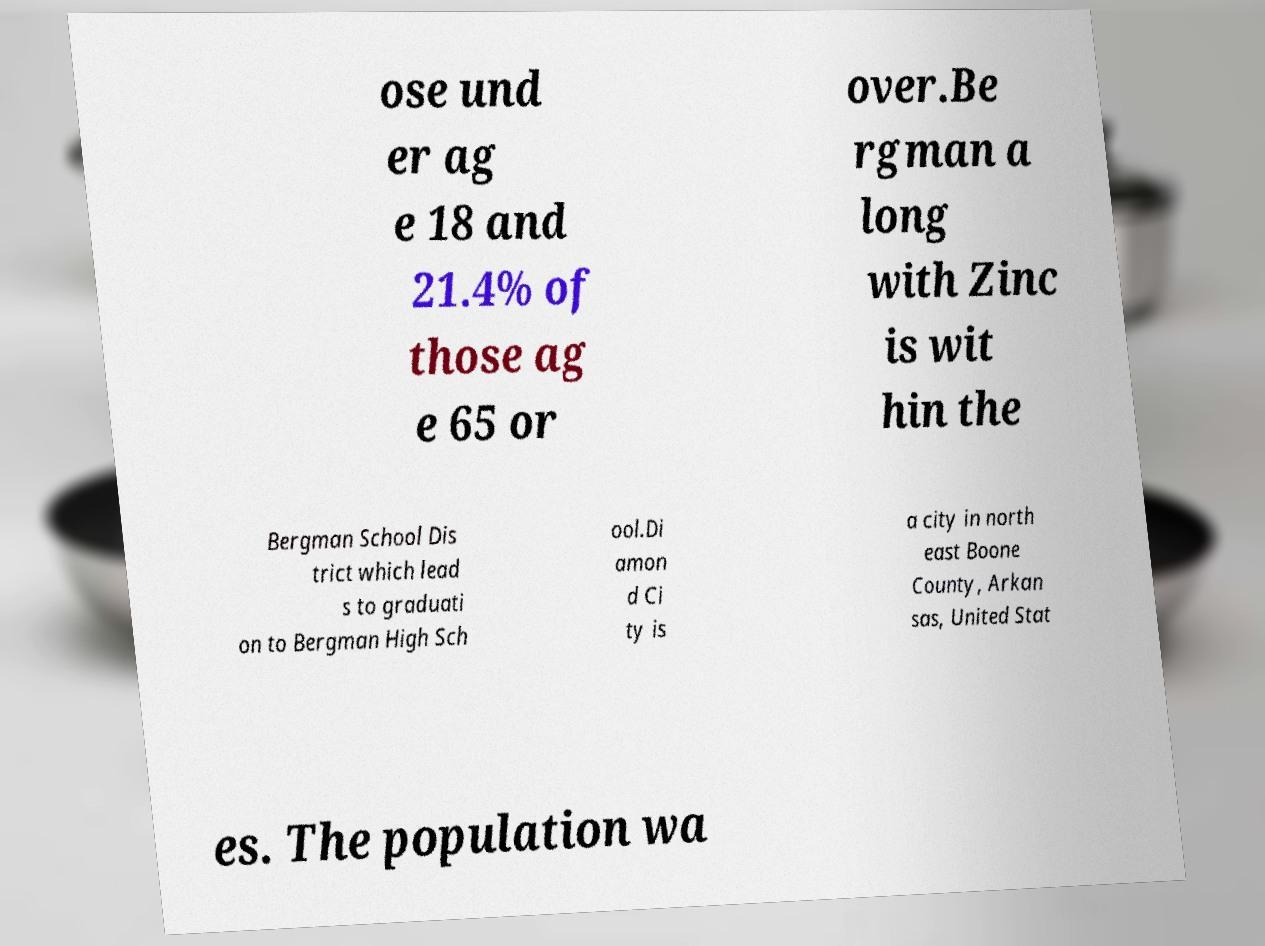Please read and relay the text visible in this image. What does it say? ose und er ag e 18 and 21.4% of those ag e 65 or over.Be rgman a long with Zinc is wit hin the Bergman School Dis trict which lead s to graduati on to Bergman High Sch ool.Di amon d Ci ty is a city in north east Boone County, Arkan sas, United Stat es. The population wa 